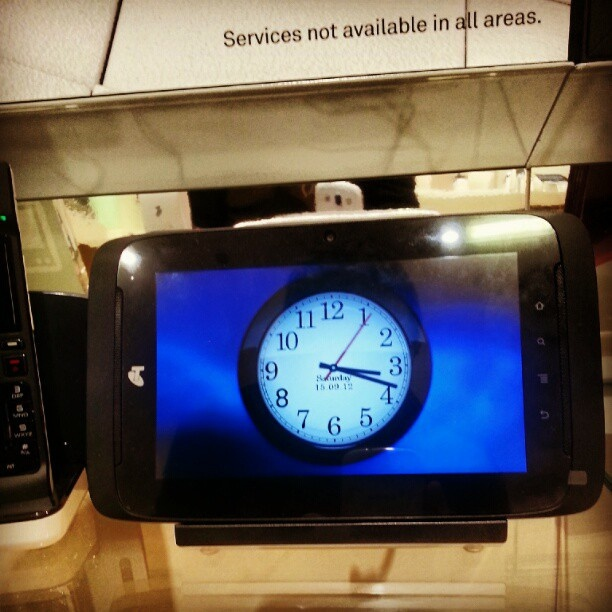Describe the objects in this image and their specific colors. I can see cell phone in gray, black, blue, darkblue, and lightblue tones, clock in gray, lightblue, black, and navy tones, and cell phone in gray, black, and maroon tones in this image. 